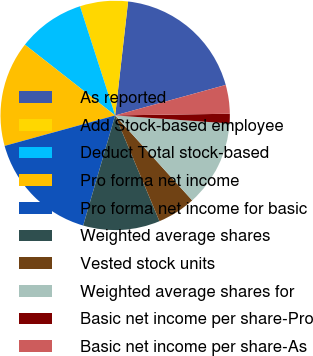Convert chart. <chart><loc_0><loc_0><loc_500><loc_500><pie_chart><fcel>As reported<fcel>Add Stock-based employee<fcel>Deduct Total stock-based<fcel>Pro forma net income<fcel>Pro forma net income for basic<fcel>Weighted average shares<fcel>Vested stock units<fcel>Weighted average shares for<fcel>Basic net income per share-Pro<fcel>Basic net income per share-As<nl><fcel>18.92%<fcel>6.76%<fcel>9.46%<fcel>14.86%<fcel>16.22%<fcel>10.81%<fcel>5.41%<fcel>12.16%<fcel>1.35%<fcel>4.05%<nl></chart> 